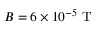<formula> <loc_0><loc_0><loc_500><loc_500>B = 6 \times 1 0 ^ { - 5 } T</formula> 